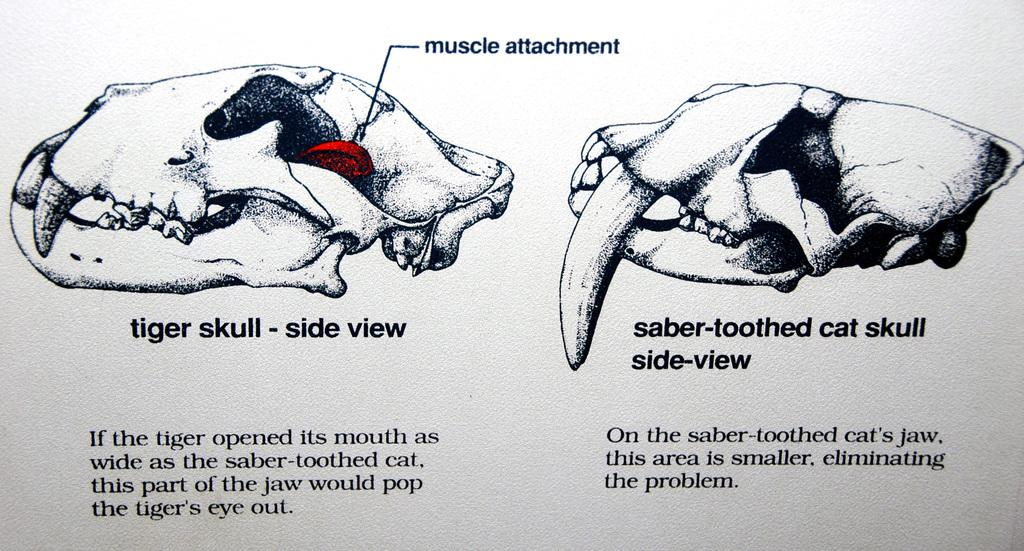What type of images are on the paper in the image? There are pictures of skulls on the paper. What else can be found at the bottom of the paper? There is text at the bottom of the paper. What type of apparel is being washed in the tub in the image? There is no tub or apparel present in the image. How much waste is visible in the image? There is no waste visible in the image. 